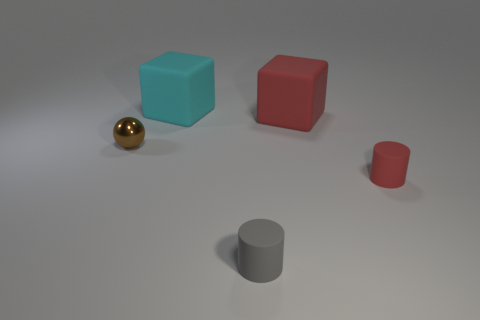What number of things are big red things or red rubber objects that are behind the tiny shiny thing?
Your answer should be very brief. 1. What is the material of the ball?
Ensure brevity in your answer.  Metal. Is there any other thing that is the same color as the shiny sphere?
Provide a short and direct response. No. Is the shape of the gray object the same as the tiny red matte thing?
Offer a terse response. Yes. How big is the cyan rubber cube behind the small thing on the right side of the small cylinder to the left of the large red rubber object?
Your answer should be compact. Large. What number of other objects are the same material as the red cylinder?
Provide a succinct answer. 3. There is a tiny cylinder that is to the right of the big red rubber cube; what color is it?
Ensure brevity in your answer.  Red. There is a big object right of the tiny matte cylinder that is left of the tiny rubber object that is on the right side of the gray cylinder; what is it made of?
Keep it short and to the point. Rubber. Is there another metallic object of the same shape as the small red object?
Ensure brevity in your answer.  No. What shape is the brown object that is the same size as the gray matte cylinder?
Your answer should be compact. Sphere. 